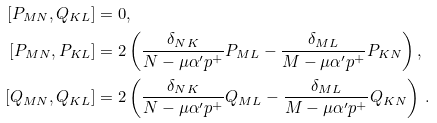Convert formula to latex. <formula><loc_0><loc_0><loc_500><loc_500>[ P _ { M N } , Q _ { K L } ] & = 0 , \\ [ P _ { M N } , P _ { K L } ] & = 2 \left ( \frac { \delta _ { N K } } { N - \mu \alpha ^ { \prime } p ^ { + } } P _ { M L } - \frac { \delta _ { M L } } { M - \mu \alpha ^ { \prime } p ^ { + } } P _ { K N } \right ) , \\ [ Q _ { M N } , Q _ { K L } ] & = 2 \left ( \frac { \delta _ { N K } } { N - \mu \alpha ^ { \prime } p ^ { + } } Q _ { M L } - \frac { \delta _ { M L } } { M - \mu \alpha ^ { \prime } p ^ { + } } Q _ { K N } \right ) \, .</formula> 